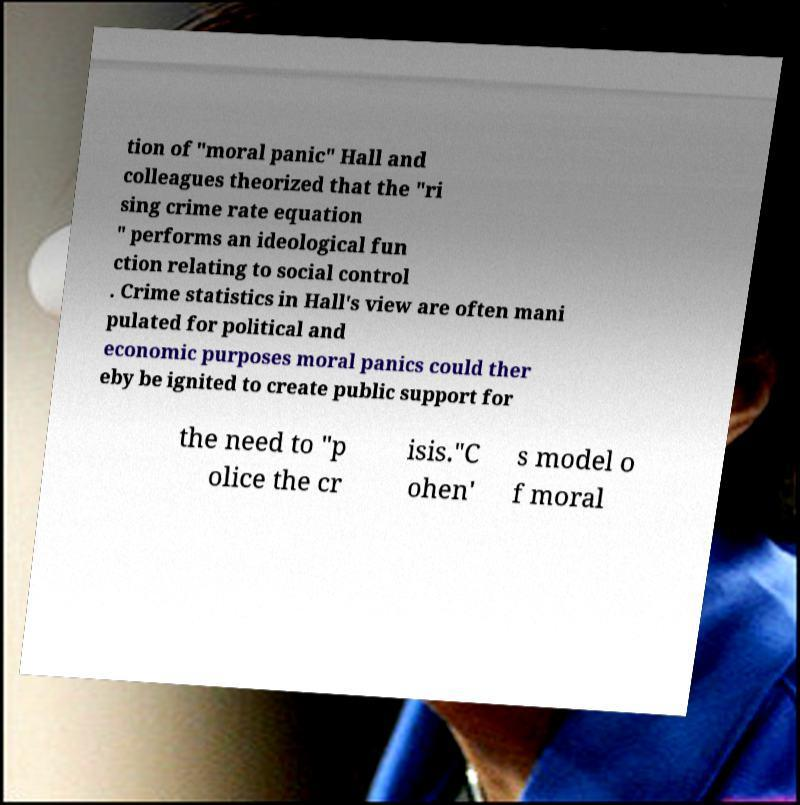For documentation purposes, I need the text within this image transcribed. Could you provide that? tion of "moral panic" Hall and colleagues theorized that the "ri sing crime rate equation " performs an ideological fun ction relating to social control . Crime statistics in Hall's view are often mani pulated for political and economic purposes moral panics could ther eby be ignited to create public support for the need to "p olice the cr isis."C ohen' s model o f moral 